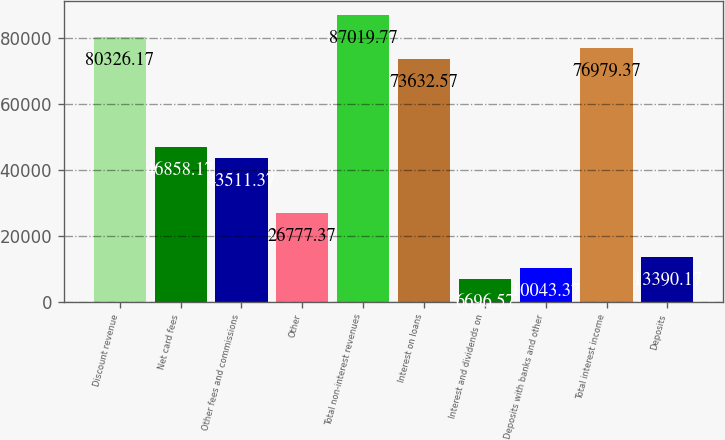Convert chart to OTSL. <chart><loc_0><loc_0><loc_500><loc_500><bar_chart><fcel>Discount revenue<fcel>Net card fees<fcel>Other fees and commissions<fcel>Other<fcel>Total non-interest revenues<fcel>Interest on loans<fcel>Interest and dividends on<fcel>Deposits with banks and other<fcel>Total interest income<fcel>Deposits<nl><fcel>80326.2<fcel>46858.2<fcel>43511.4<fcel>26777.4<fcel>87019.8<fcel>73632.6<fcel>6696.57<fcel>10043.4<fcel>76979.4<fcel>13390.2<nl></chart> 